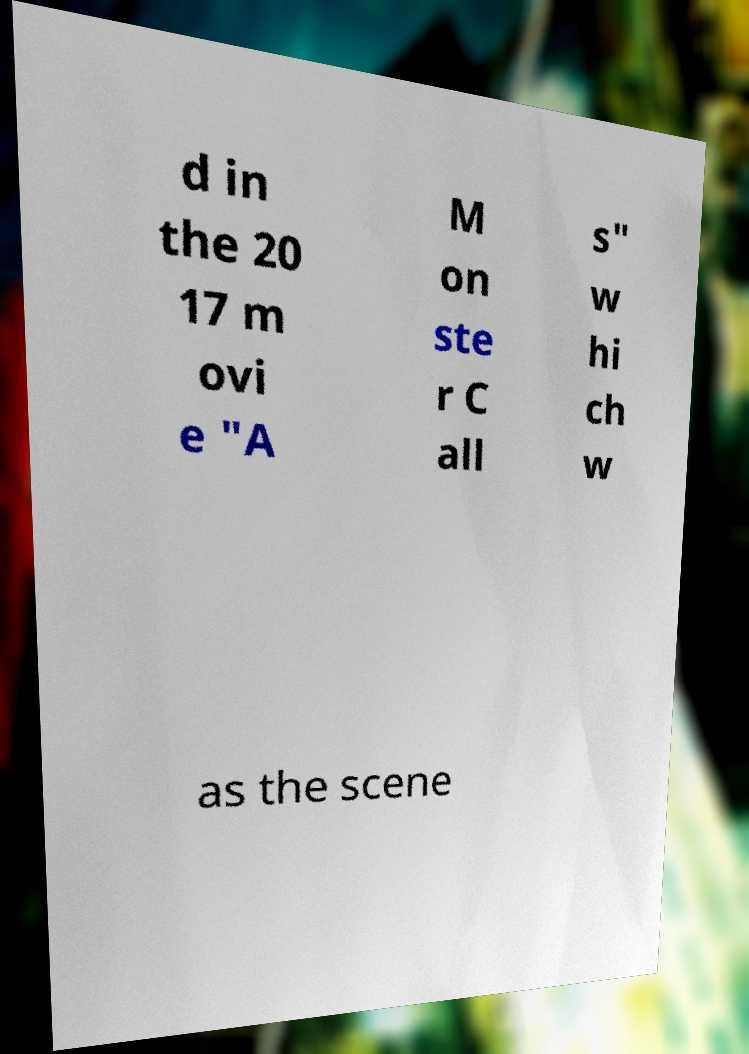Please read and relay the text visible in this image. What does it say? d in the 20 17 m ovi e "A M on ste r C all s" w hi ch w as the scene 